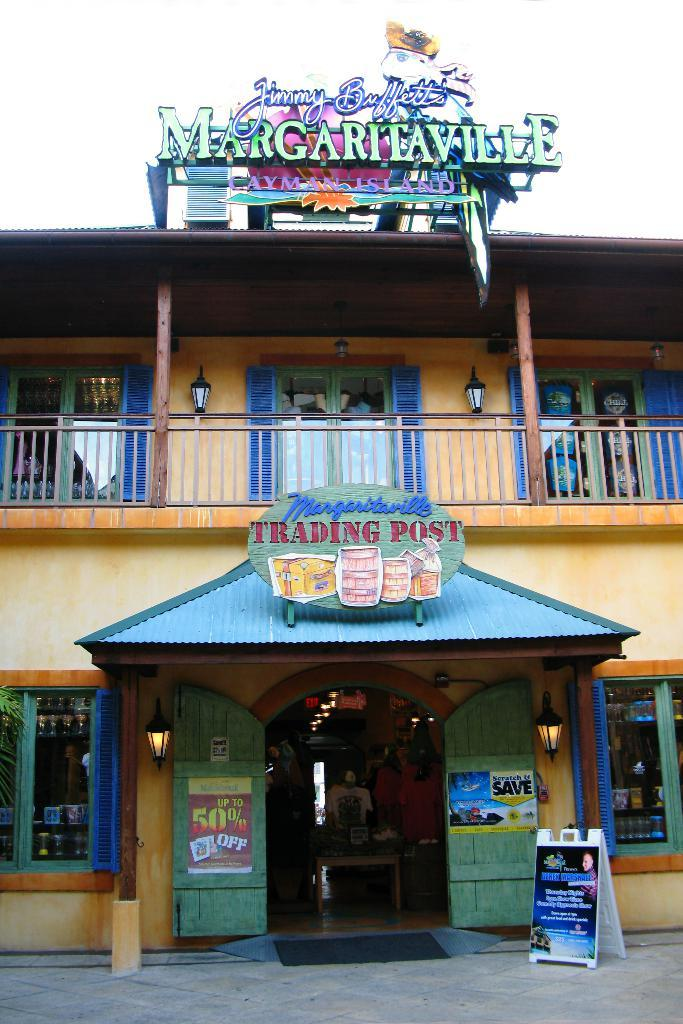What is the main structure in the center of the image? There is a building in the center of the image. What can be seen in the same area as the building? There are lights in the center of the image. What is located at the bottom of the image? There is a board at the bottom of the image. What type of surface is visible at the bottom of the image? The ground is visible at the bottom of the image. What is visible in the background of the image? The sky is visible in the background of the image. How many balls are being used to support the building in the image? There are no balls present in the image, and they are not used to support the building. 